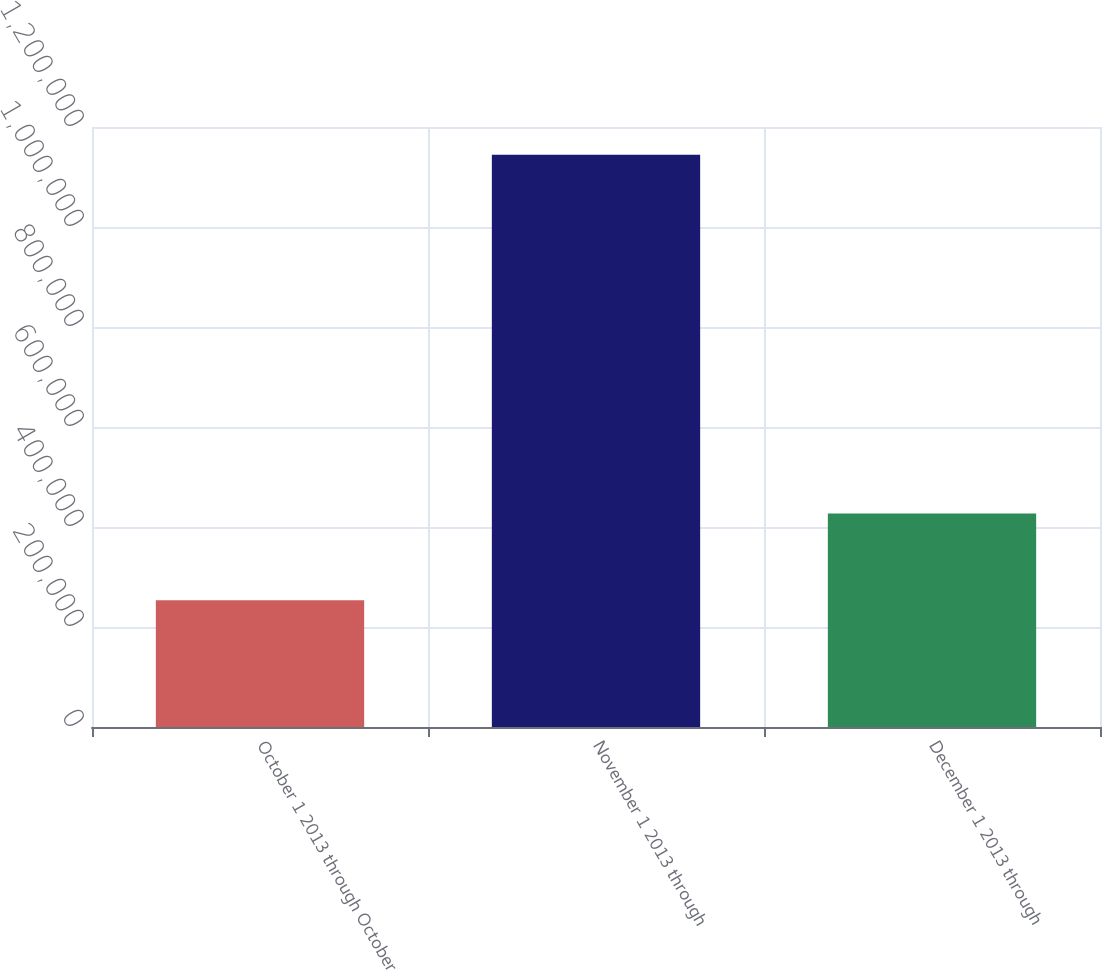<chart> <loc_0><loc_0><loc_500><loc_500><bar_chart><fcel>October 1 2013 through October<fcel>November 1 2013 through<fcel>December 1 2013 through<nl><fcel>253676<fcel>1.14434e+06<fcel>426970<nl></chart> 